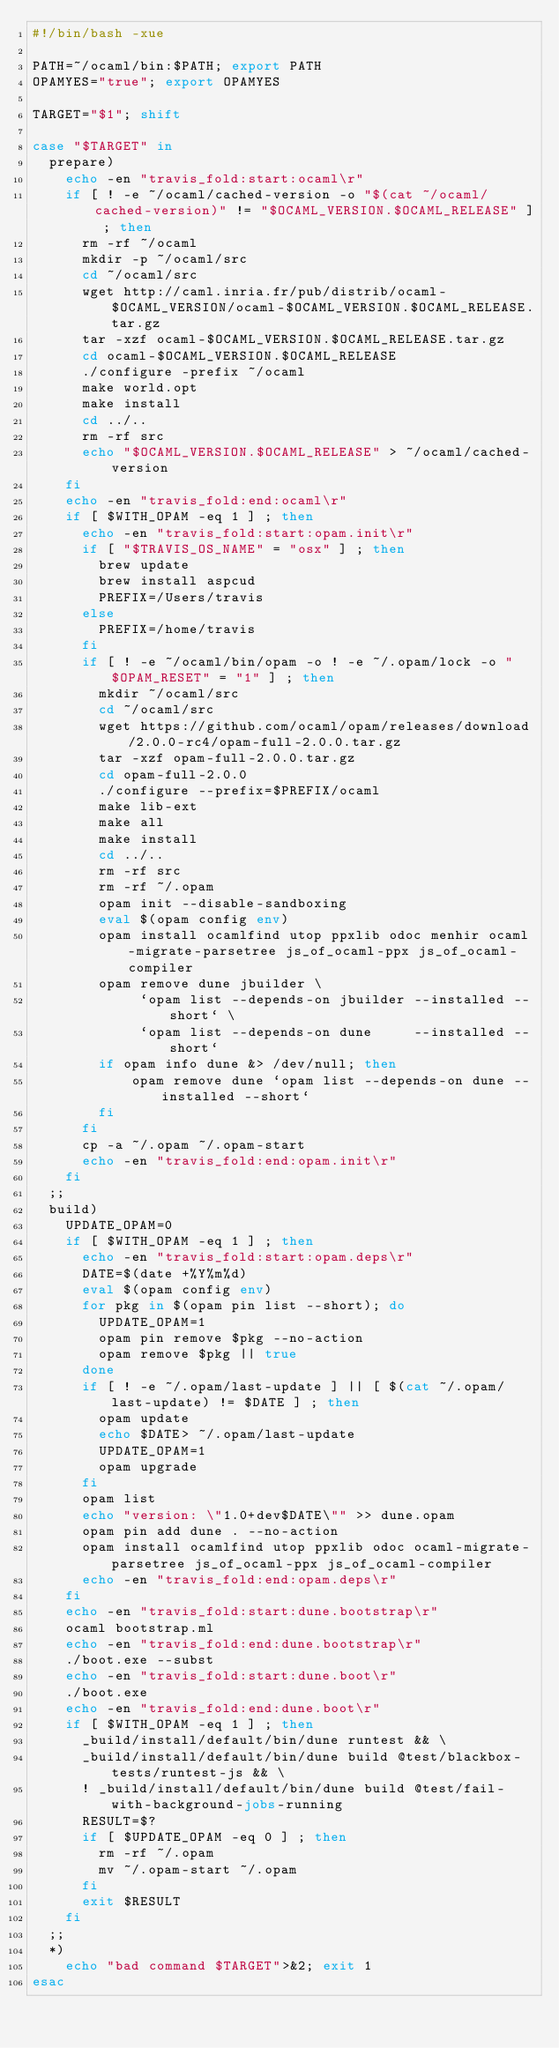<code> <loc_0><loc_0><loc_500><loc_500><_Bash_>#!/bin/bash -xue

PATH=~/ocaml/bin:$PATH; export PATH
OPAMYES="true"; export OPAMYES

TARGET="$1"; shift

case "$TARGET" in
  prepare)
    echo -en "travis_fold:start:ocaml\r"
    if [ ! -e ~/ocaml/cached-version -o "$(cat ~/ocaml/cached-version)" != "$OCAML_VERSION.$OCAML_RELEASE" ] ; then
      rm -rf ~/ocaml
      mkdir -p ~/ocaml/src
      cd ~/ocaml/src
      wget http://caml.inria.fr/pub/distrib/ocaml-$OCAML_VERSION/ocaml-$OCAML_VERSION.$OCAML_RELEASE.tar.gz
      tar -xzf ocaml-$OCAML_VERSION.$OCAML_RELEASE.tar.gz
      cd ocaml-$OCAML_VERSION.$OCAML_RELEASE
      ./configure -prefix ~/ocaml
      make world.opt
      make install
      cd ../..
      rm -rf src
      echo "$OCAML_VERSION.$OCAML_RELEASE" > ~/ocaml/cached-version
    fi
    echo -en "travis_fold:end:ocaml\r"
    if [ $WITH_OPAM -eq 1 ] ; then
      echo -en "travis_fold:start:opam.init\r"
      if [ "$TRAVIS_OS_NAME" = "osx" ] ; then
        brew update
        brew install aspcud
        PREFIX=/Users/travis
      else
        PREFIX=/home/travis
      fi
      if [ ! -e ~/ocaml/bin/opam -o ! -e ~/.opam/lock -o "$OPAM_RESET" = "1" ] ; then
        mkdir ~/ocaml/src
        cd ~/ocaml/src
        wget https://github.com/ocaml/opam/releases/download/2.0.0-rc4/opam-full-2.0.0.tar.gz
        tar -xzf opam-full-2.0.0.tar.gz
        cd opam-full-2.0.0
        ./configure --prefix=$PREFIX/ocaml
        make lib-ext
        make all
        make install
        cd ../..
        rm -rf src
        rm -rf ~/.opam
        opam init --disable-sandboxing
        eval $(opam config env)
        opam install ocamlfind utop ppxlib odoc menhir ocaml-migrate-parsetree js_of_ocaml-ppx js_of_ocaml-compiler
        opam remove dune jbuilder \
             `opam list --depends-on jbuilder --installed --short` \
             `opam list --depends-on dune     --installed --short`
        if opam info dune &> /dev/null; then
            opam remove dune `opam list --depends-on dune --installed --short`
        fi
      fi
      cp -a ~/.opam ~/.opam-start
      echo -en "travis_fold:end:opam.init\r"
    fi
  ;;
  build)
    UPDATE_OPAM=0
    if [ $WITH_OPAM -eq 1 ] ; then
      echo -en "travis_fold:start:opam.deps\r"
      DATE=$(date +%Y%m%d)
      eval $(opam config env)
      for pkg in $(opam pin list --short); do
        UPDATE_OPAM=1
        opam pin remove $pkg --no-action
        opam remove $pkg || true
      done
      if [ ! -e ~/.opam/last-update ] || [ $(cat ~/.opam/last-update) != $DATE ] ; then
        opam update
        echo $DATE> ~/.opam/last-update
        UPDATE_OPAM=1
        opam upgrade
      fi
      opam list
      echo "version: \"1.0+dev$DATE\"" >> dune.opam
      opam pin add dune . --no-action
      opam install ocamlfind utop ppxlib odoc ocaml-migrate-parsetree js_of_ocaml-ppx js_of_ocaml-compiler
      echo -en "travis_fold:end:opam.deps\r"
    fi
    echo -en "travis_fold:start:dune.bootstrap\r"
    ocaml bootstrap.ml
    echo -en "travis_fold:end:dune.bootstrap\r"
    ./boot.exe --subst
    echo -en "travis_fold:start:dune.boot\r"
    ./boot.exe
    echo -en "travis_fold:end:dune.boot\r"
    if [ $WITH_OPAM -eq 1 ] ; then
      _build/install/default/bin/dune runtest && \
      _build/install/default/bin/dune build @test/blackbox-tests/runtest-js && \
      ! _build/install/default/bin/dune build @test/fail-with-background-jobs-running
      RESULT=$?
      if [ $UPDATE_OPAM -eq 0 ] ; then
        rm -rf ~/.opam
        mv ~/.opam-start ~/.opam
      fi
      exit $RESULT
    fi
  ;;
  *)
    echo "bad command $TARGET">&2; exit 1
esac
</code> 